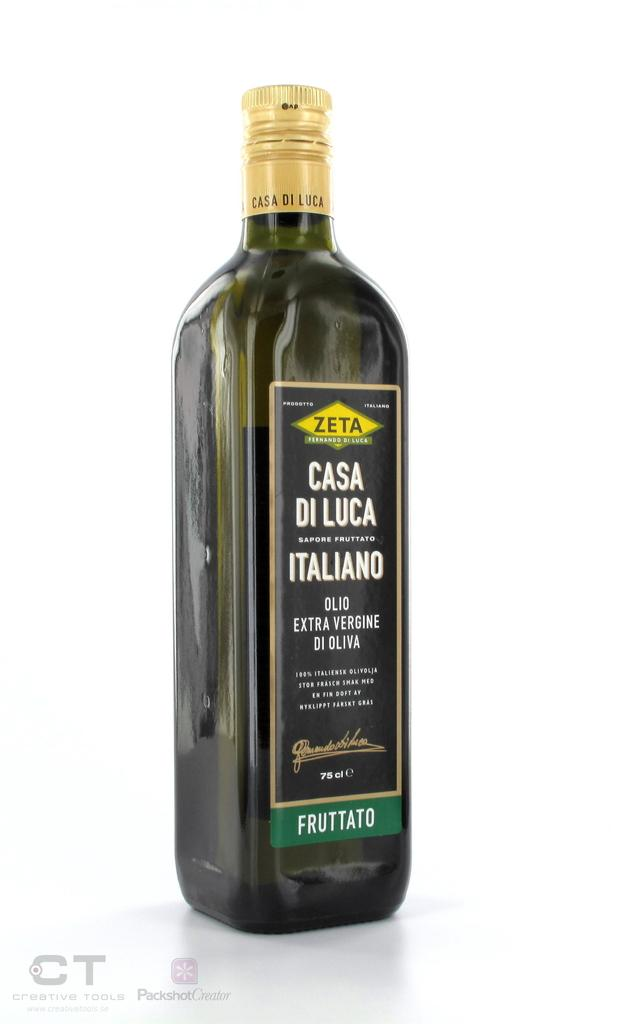<image>
Render a clear and concise summary of the photo. the name of the bottle is casa di luca 